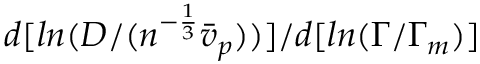Convert formula to latex. <formula><loc_0><loc_0><loc_500><loc_500>d [ \ln ( D / ( n ^ { - \frac { 1 } { 3 } } \bar { v } _ { p } ) ) ] / d [ \ln ( \Gamma / \Gamma _ { m } ) ]</formula> 